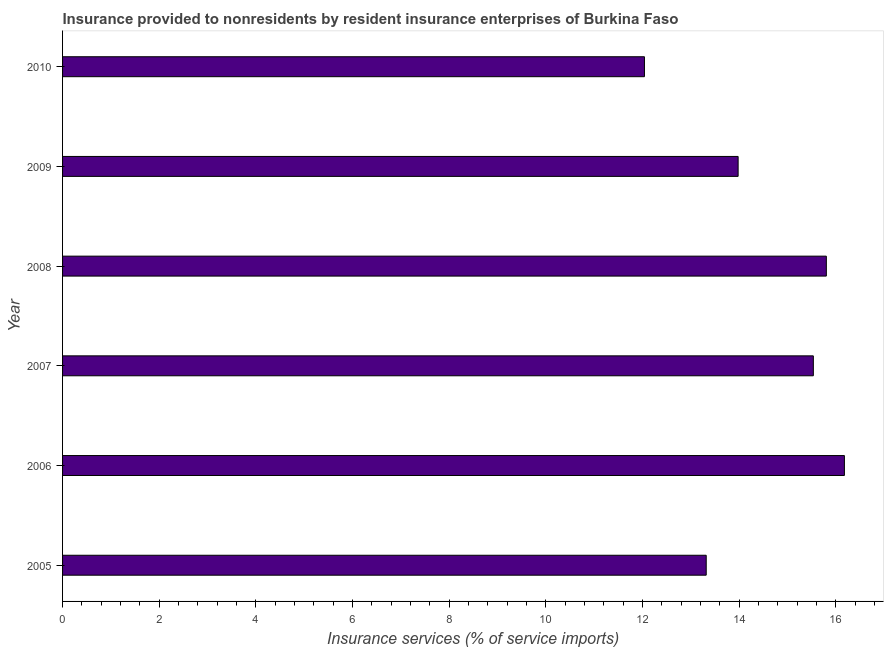Does the graph contain grids?
Keep it short and to the point. No. What is the title of the graph?
Your response must be concise. Insurance provided to nonresidents by resident insurance enterprises of Burkina Faso. What is the label or title of the X-axis?
Make the answer very short. Insurance services (% of service imports). What is the insurance and financial services in 2008?
Your answer should be compact. 15.81. Across all years, what is the maximum insurance and financial services?
Provide a succinct answer. 16.18. Across all years, what is the minimum insurance and financial services?
Make the answer very short. 12.04. In which year was the insurance and financial services minimum?
Your response must be concise. 2010. What is the sum of the insurance and financial services?
Provide a succinct answer. 86.87. What is the difference between the insurance and financial services in 2006 and 2009?
Provide a short and direct response. 2.2. What is the average insurance and financial services per year?
Make the answer very short. 14.48. What is the median insurance and financial services?
Provide a short and direct response. 14.76. Do a majority of the years between 2008 and 2006 (inclusive) have insurance and financial services greater than 13.6 %?
Your answer should be compact. Yes. Is the insurance and financial services in 2009 less than that in 2010?
Provide a short and direct response. No. Is the difference between the insurance and financial services in 2005 and 2007 greater than the difference between any two years?
Give a very brief answer. No. What is the difference between the highest and the second highest insurance and financial services?
Your answer should be compact. 0.37. Is the sum of the insurance and financial services in 2008 and 2009 greater than the maximum insurance and financial services across all years?
Keep it short and to the point. Yes. What is the difference between the highest and the lowest insurance and financial services?
Offer a terse response. 4.14. How many bars are there?
Keep it short and to the point. 6. How many years are there in the graph?
Keep it short and to the point. 6. What is the difference between two consecutive major ticks on the X-axis?
Give a very brief answer. 2. What is the Insurance services (% of service imports) of 2005?
Offer a terse response. 13.32. What is the Insurance services (% of service imports) in 2006?
Ensure brevity in your answer.  16.18. What is the Insurance services (% of service imports) of 2007?
Offer a very short reply. 15.54. What is the Insurance services (% of service imports) in 2008?
Offer a terse response. 15.81. What is the Insurance services (% of service imports) in 2009?
Offer a very short reply. 13.98. What is the Insurance services (% of service imports) of 2010?
Ensure brevity in your answer.  12.04. What is the difference between the Insurance services (% of service imports) in 2005 and 2006?
Offer a terse response. -2.86. What is the difference between the Insurance services (% of service imports) in 2005 and 2007?
Keep it short and to the point. -2.22. What is the difference between the Insurance services (% of service imports) in 2005 and 2008?
Provide a succinct answer. -2.49. What is the difference between the Insurance services (% of service imports) in 2005 and 2009?
Provide a succinct answer. -0.66. What is the difference between the Insurance services (% of service imports) in 2005 and 2010?
Provide a succinct answer. 1.28. What is the difference between the Insurance services (% of service imports) in 2006 and 2007?
Your answer should be compact. 0.64. What is the difference between the Insurance services (% of service imports) in 2006 and 2008?
Give a very brief answer. 0.37. What is the difference between the Insurance services (% of service imports) in 2006 and 2009?
Provide a succinct answer. 2.2. What is the difference between the Insurance services (% of service imports) in 2006 and 2010?
Provide a short and direct response. 4.14. What is the difference between the Insurance services (% of service imports) in 2007 and 2008?
Offer a terse response. -0.27. What is the difference between the Insurance services (% of service imports) in 2007 and 2009?
Your answer should be very brief. 1.56. What is the difference between the Insurance services (% of service imports) in 2007 and 2010?
Make the answer very short. 3.5. What is the difference between the Insurance services (% of service imports) in 2008 and 2009?
Provide a short and direct response. 1.83. What is the difference between the Insurance services (% of service imports) in 2008 and 2010?
Your answer should be compact. 3.76. What is the difference between the Insurance services (% of service imports) in 2009 and 2010?
Ensure brevity in your answer.  1.94. What is the ratio of the Insurance services (% of service imports) in 2005 to that in 2006?
Offer a terse response. 0.82. What is the ratio of the Insurance services (% of service imports) in 2005 to that in 2007?
Make the answer very short. 0.86. What is the ratio of the Insurance services (% of service imports) in 2005 to that in 2008?
Offer a very short reply. 0.84. What is the ratio of the Insurance services (% of service imports) in 2005 to that in 2009?
Give a very brief answer. 0.95. What is the ratio of the Insurance services (% of service imports) in 2005 to that in 2010?
Provide a succinct answer. 1.11. What is the ratio of the Insurance services (% of service imports) in 2006 to that in 2007?
Offer a terse response. 1.04. What is the ratio of the Insurance services (% of service imports) in 2006 to that in 2008?
Your answer should be compact. 1.02. What is the ratio of the Insurance services (% of service imports) in 2006 to that in 2009?
Keep it short and to the point. 1.16. What is the ratio of the Insurance services (% of service imports) in 2006 to that in 2010?
Your response must be concise. 1.34. What is the ratio of the Insurance services (% of service imports) in 2007 to that in 2009?
Make the answer very short. 1.11. What is the ratio of the Insurance services (% of service imports) in 2007 to that in 2010?
Offer a terse response. 1.29. What is the ratio of the Insurance services (% of service imports) in 2008 to that in 2009?
Give a very brief answer. 1.13. What is the ratio of the Insurance services (% of service imports) in 2008 to that in 2010?
Your response must be concise. 1.31. What is the ratio of the Insurance services (% of service imports) in 2009 to that in 2010?
Make the answer very short. 1.16. 